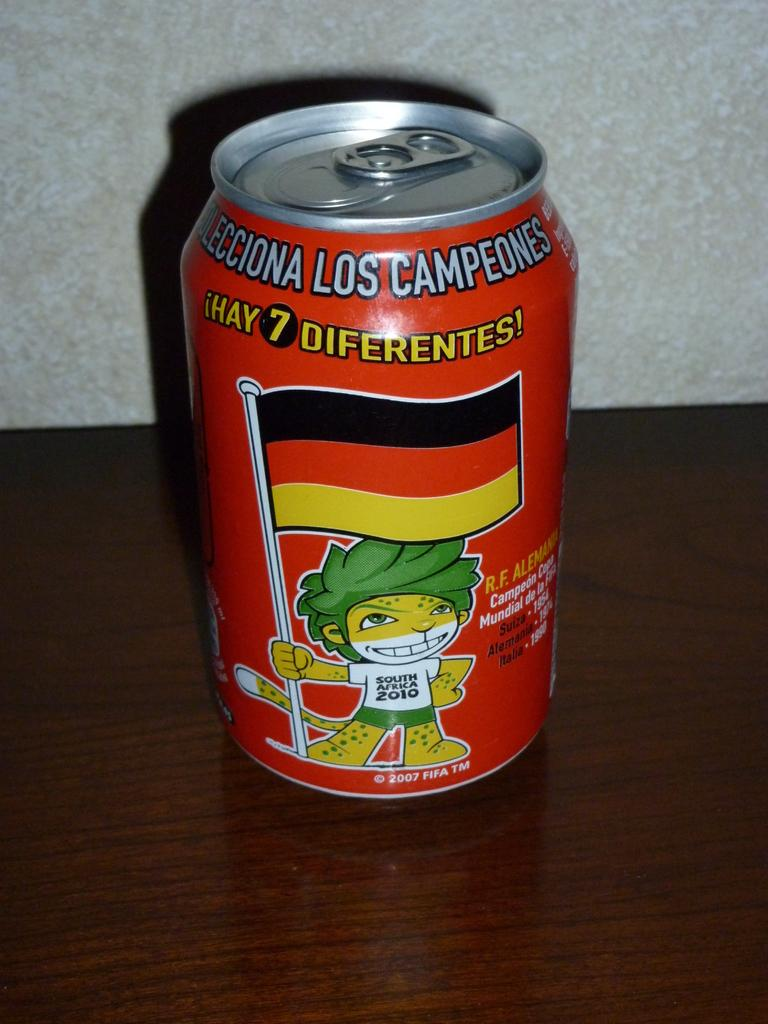<image>
Relay a brief, clear account of the picture shown. A canned drink with a graphic of a lion wearing a South Africa 2010 shirt holding a flag on the front. 